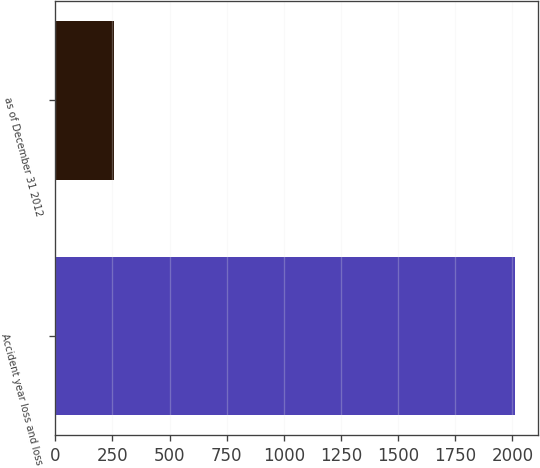<chart> <loc_0><loc_0><loc_500><loc_500><bar_chart><fcel>Accident year loss and loss<fcel>as of December 31 2012<nl><fcel>2010<fcel>258<nl></chart> 